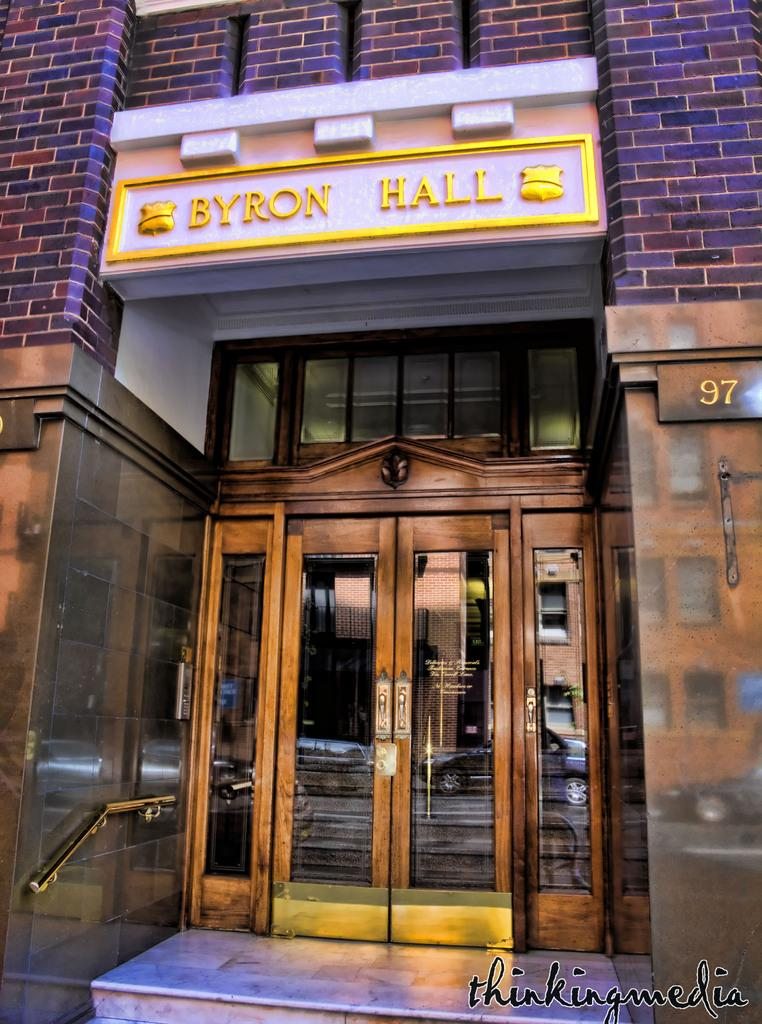What is the main subject of the image? The main subject of the image is a building. Can you describe any specific features of the building? The image shows the front view of the building. What is one of the main entry points of the building? There is a door in the image. Is there any additional information displayed on the building? A banner is present in the image. What type of book is the friend holding in the image? There is no friend or book present in the image; it only shows the front view of a building with a door and a banner. 